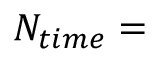Convert formula to latex. <formula><loc_0><loc_0><loc_500><loc_500>N _ { t i m e } =</formula> 